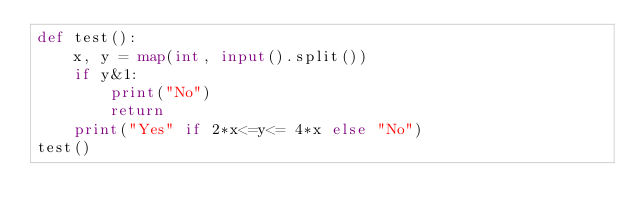Convert code to text. <code><loc_0><loc_0><loc_500><loc_500><_Python_>def test():
    x, y = map(int, input().split())
    if y&1:
        print("No")
        return
    print("Yes" if 2*x<=y<= 4*x else "No")
test()</code> 